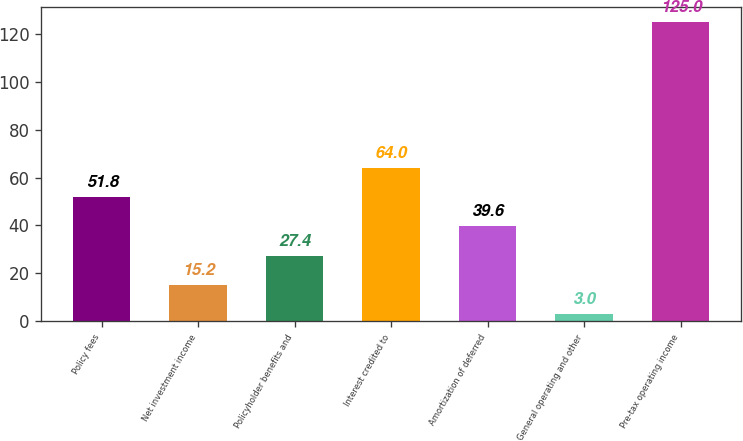<chart> <loc_0><loc_0><loc_500><loc_500><bar_chart><fcel>Policy fees<fcel>Net investment income<fcel>Policyholder benefits and<fcel>Interest credited to<fcel>Amortization of deferred<fcel>General operating and other<fcel>Pre-tax operating income<nl><fcel>51.8<fcel>15.2<fcel>27.4<fcel>64<fcel>39.6<fcel>3<fcel>125<nl></chart> 